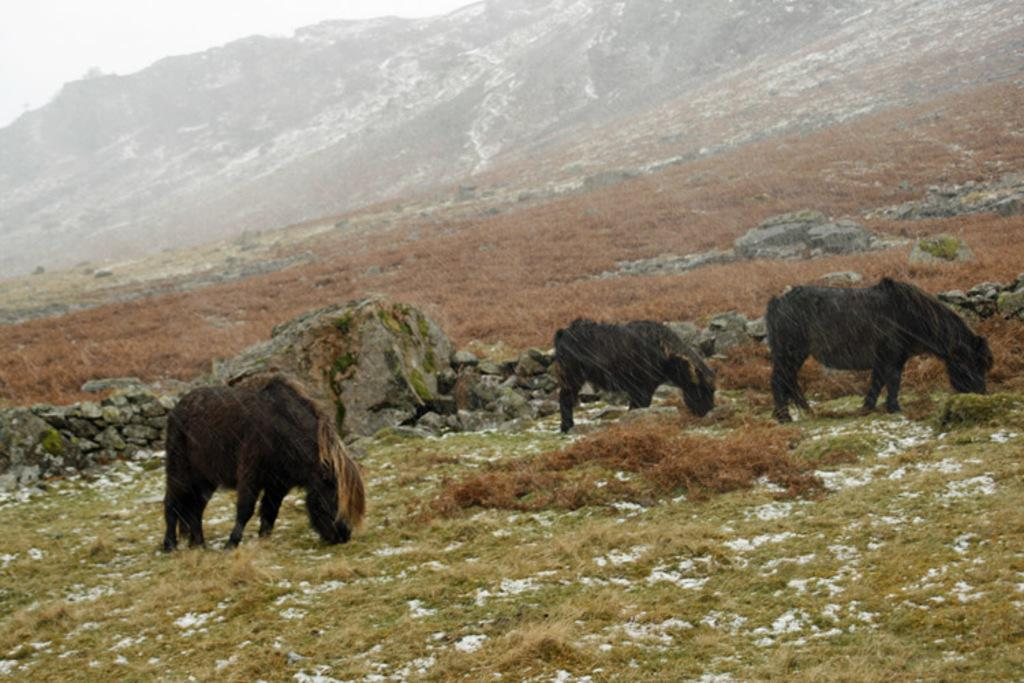What type of living organisms can be seen in the image? There are animals in the image. What are the animals doing in the image? The animals are grazing grass. Where is the grass located in the image? The grass is on the ground. What can be seen in the background of the image? There is a hill in the background of the image. What type of wound can be seen on the hill in the image? There is no wound present in the image, as the hill is a natural geographical feature and not a living organism. 